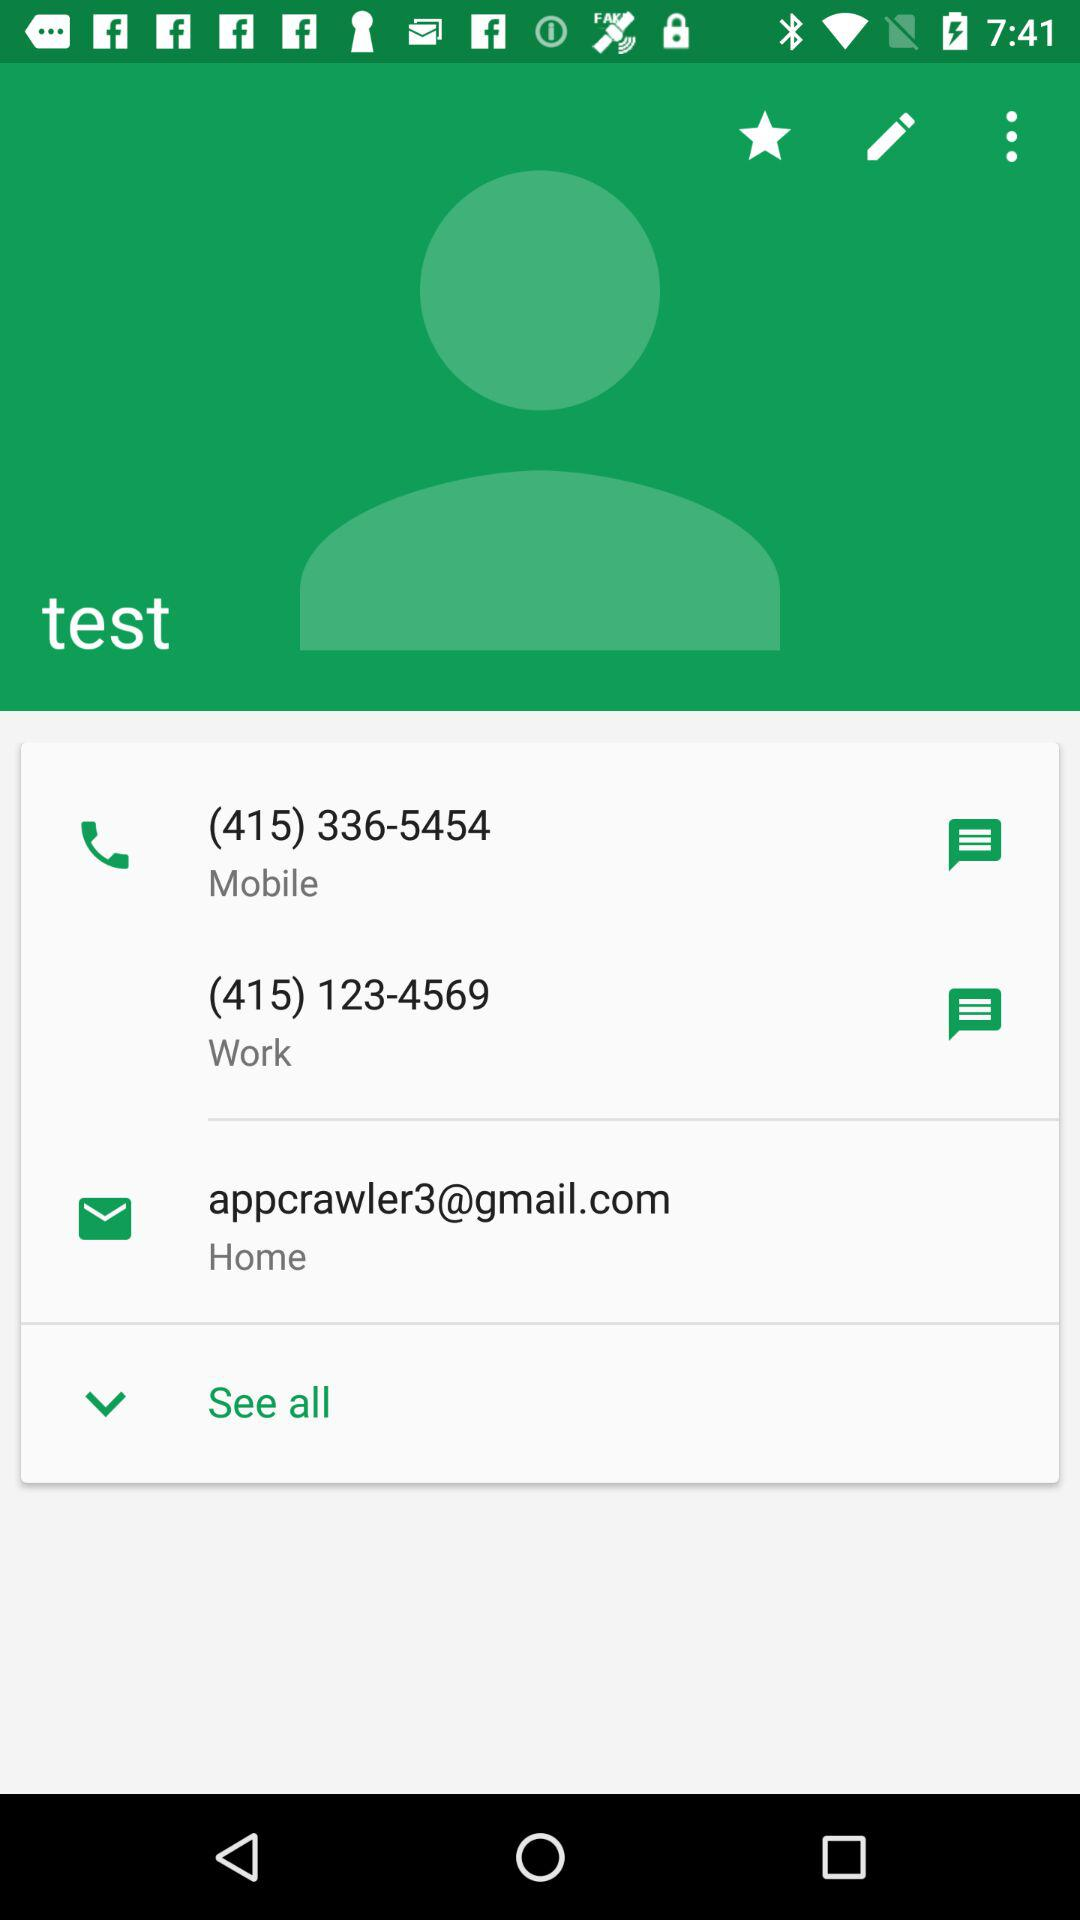What are the mobile numbers? The mobile numbers are (415) 336-5454 and (415) 123-4569. 